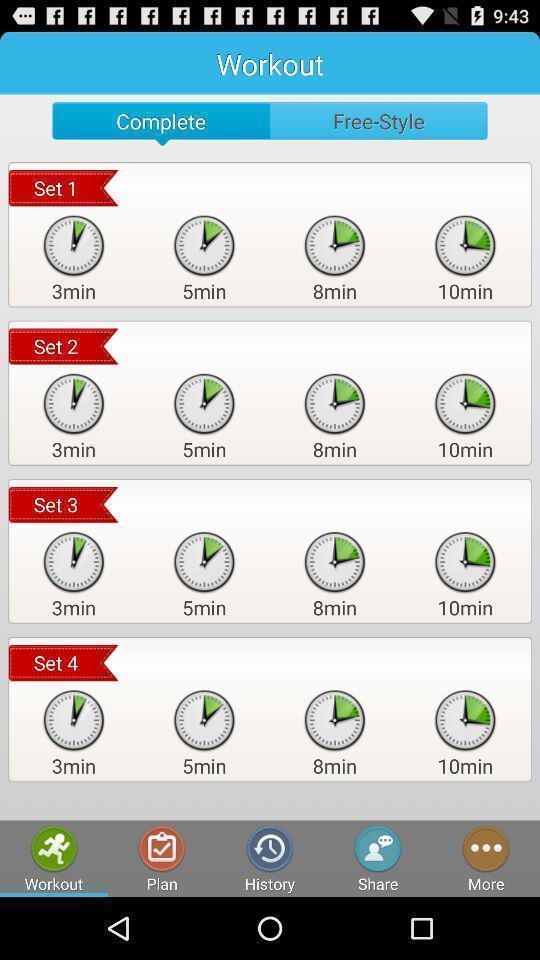Describe the content in this image. Page displaying various workouts in a fitness app. 